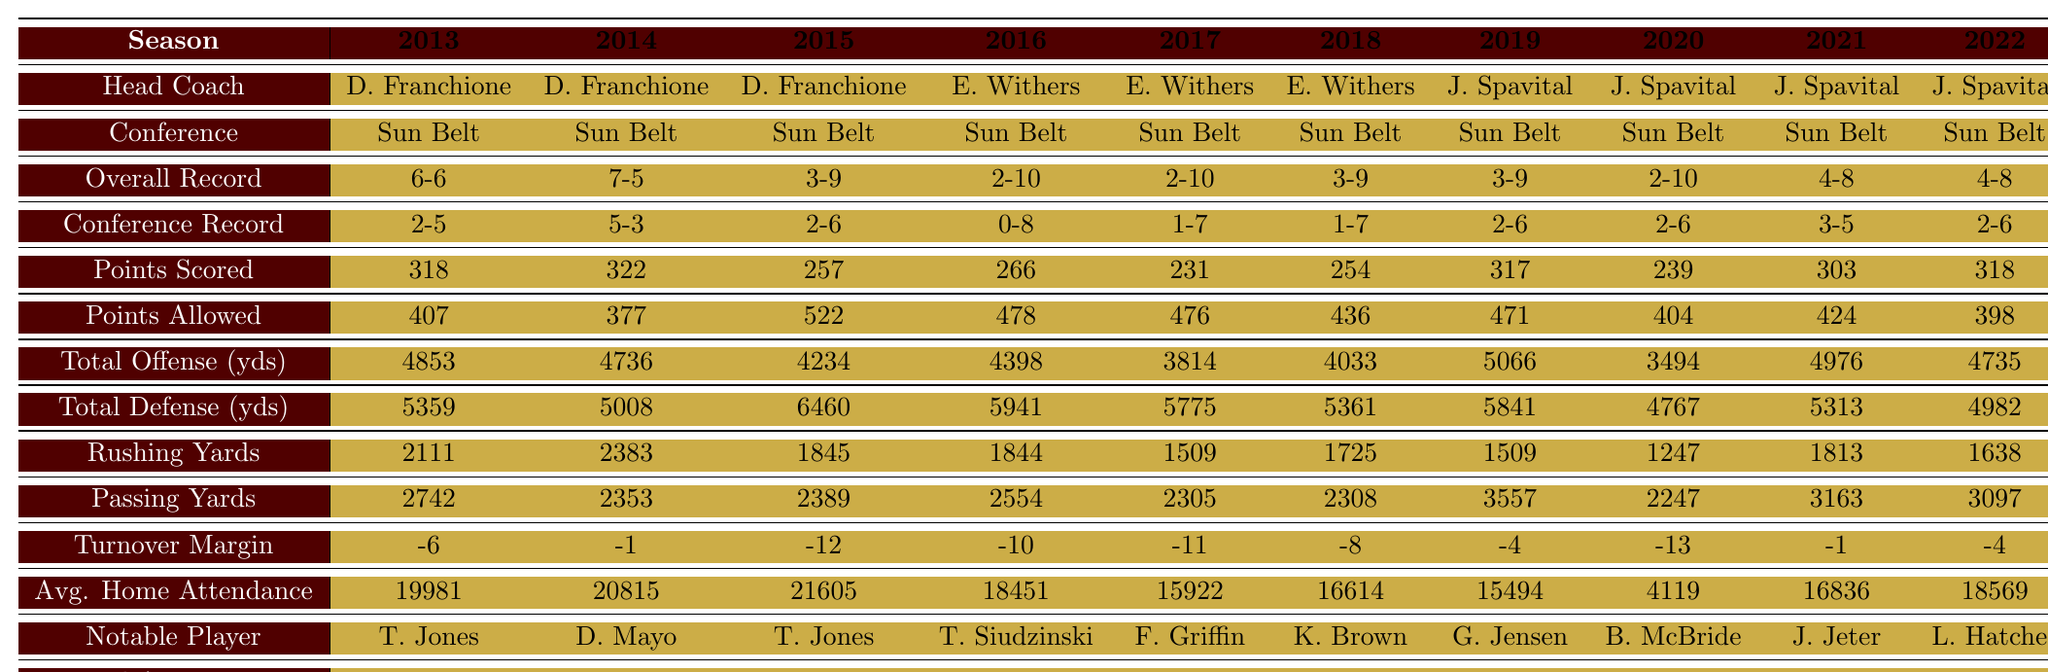What was the overall record of the Bobcats football team in 2015? The table indicates that the overall record in 2015 was 3 wins and 9 losses.
Answer: 3-9 How many points were scored by the Bobcats in the season with the best overall record? The best overall record was in 2014, which shows that the team scored 322 points that season.
Answer: 322 Did the Bobcats make any bowl appearances in the last decade? The table displays "No" under the Bowl Appearance row for each season from 2013 to 2022, indicating that they did not make any bowl appearances.
Answer: No What was the average home attendance for the Bobcats football games from 2013 to 2022? To find the average, sum up all the home attendance figures: (19981 + 20815 + 21605 + 18451 + 15922 + 16614 + 15494 + 4119 + 16836 + 18569) = 111,626. Then divide by 10 seasons: 111,626 / 10 = 11,162.6, rounding gives approximately 11,163.
Answer: 11,163 In which year did the Bobcats have the highest points allowed and what was that value? The highest points allowed was in 2015, where the team allowed 522 points according to the table.
Answer: 2015, 522 What is the difference in total offense yards between the best and worst seasons? The best season for total offense was 2019 with 5066 yards and the worst was 2020 with 3494 yards, the difference is: 5066 - 3494 = 1572 yards.
Answer: 1572 What is the notable player for the season with the highest overall record? The team had the highest overall record in 2014, and the notable player that season was David Mayo.
Answer: David Mayo How many seasons did the Bobcats have a conference record of 2-6? The conference records of 2-6 occurred in the seasons of 2015, 2019, and 2022, resulting in a total of 3 seasons.
Answer: 3 What was the turnover margin during the season with the highest passing yards? The highest passing yards were in 2019 with 3557 yards, and the turnover margin that season was -4.
Answer: -4 Which season had the lowest average home attendance? The season with the lowest average home attendance was 2020, with only 4,119 attendees.
Answer: 2020 